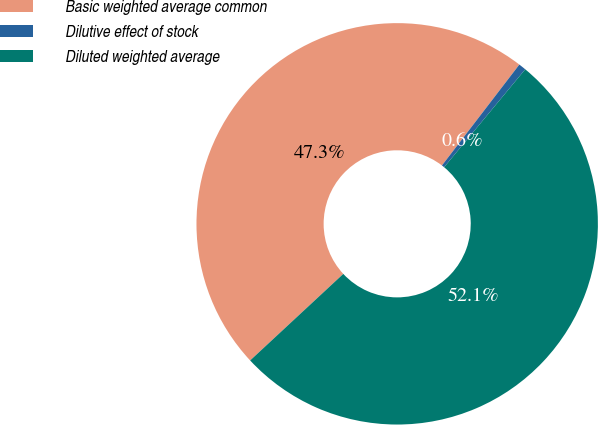Convert chart. <chart><loc_0><loc_0><loc_500><loc_500><pie_chart><fcel>Basic weighted average common<fcel>Dilutive effect of stock<fcel>Diluted weighted average<nl><fcel>47.33%<fcel>0.6%<fcel>52.07%<nl></chart> 